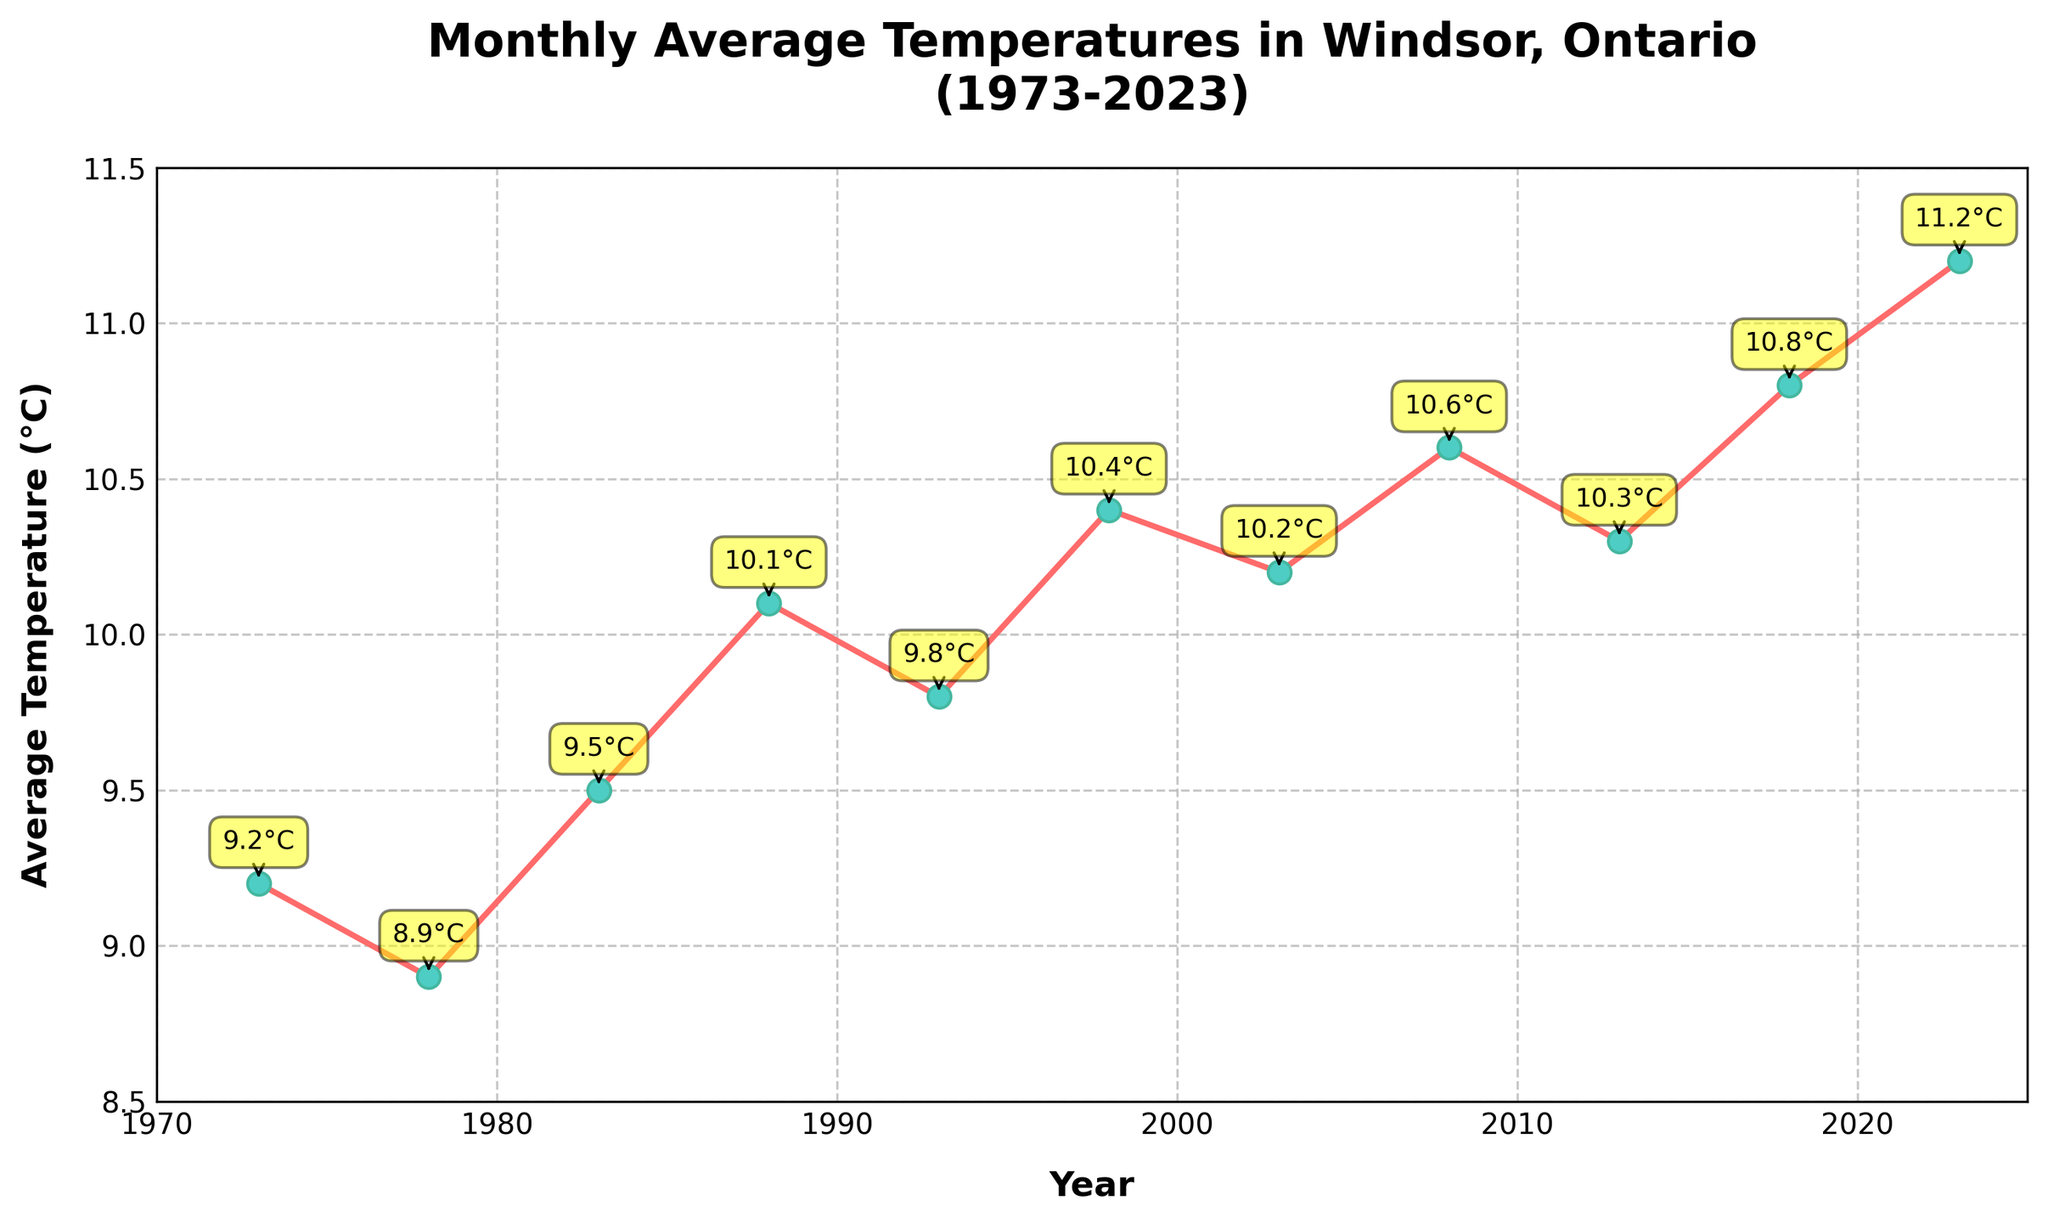Which year has the highest average temperature? By observing the height of the markers in the line chart, we can see that 2023 has the highest average temperature at 11.2°C.
Answer: 2023 How much did the average temperature increase from 1973 to 2023? The average temperature in 1973 was 9.2°C and in 2023 it was 11.2°C. The increase is calculated as 11.2 - 9.2 = 2.0°C.
Answer: 2.0°C Which year has a higher average temperature: 1988 or 1998? By comparing the data points, we see that 1998 has a higher average temperature (10.4°C) than 1988 (10.1°C).
Answer: 1998 What is the average temperature difference between 1983 and 2008? The average temperature in 1983 is 9.5°C and in 2008 it is 10.6°C. The difference is calculated as 10.6 - 9.5 = 1.1°C.
Answer: 1.1°C How many years have an average temperature above 10°C? From the line chart, the years that have an average temperature above 10°C are 1988, 1993, 1998, 2003, 2008, 2013, 2018, and 2023, totaling 8 years.
Answer: 8 years What's the trend of the average temperature from 1973 to 2023? Observing the line chart, the average temperature shows an overall increasing trend from 1973 (9.2°C) to 2023 (11.2°C), indicating a rise in average temperatures over the 50 years.
Answer: Increasing trend Which year has the most significant drop in average temperatures when compared consecutively? By examining the consecutive points on the line chart, the most significant drop is between 1973 (9.2°C) and 1978 (8.9°C) where the temperature decreases by 0.3°C.
Answer: 1978 What is the average temperature for the decade 1990-1999? The average temperatures for the 1990-1999 decade include 1993 (9.8°C) and 1998 (10.4°C). The average is calculated as (9.8 + 10.4) / 2 = 10.1°C.
Answer: 10.1°C Compare the temperatures in 2003 and 2013; which year has a higher temperature and by how much? The average temperature in 2003 is 10.2°C and in 2013 it is 10.3°C. The difference is 10.3 - 10.2 = 0.1°C. 2013 has a higher temperature by 0.1°C.
Answer: 2013, 0.1°C 